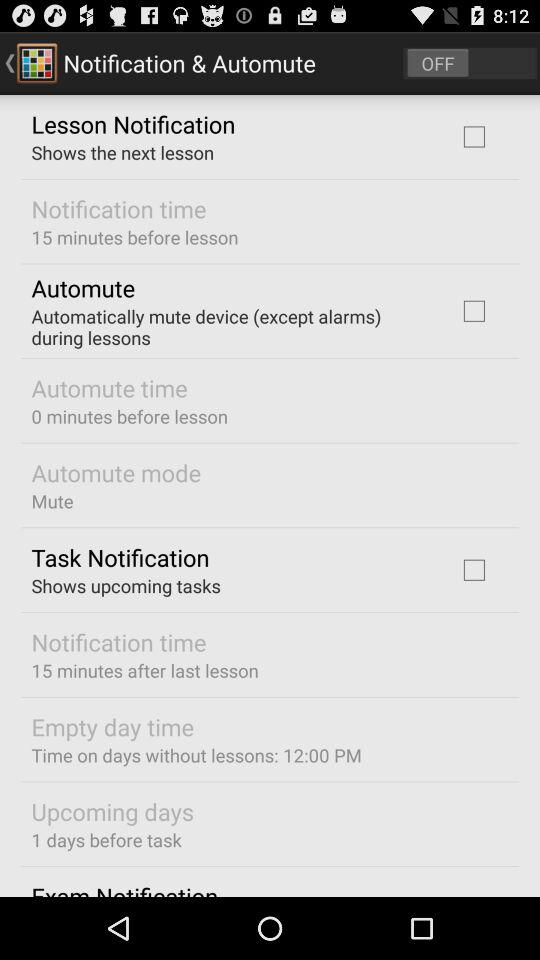How many minutes before the lesson does the notification happen?
Answer the question using a single word or phrase. 15 minutes 